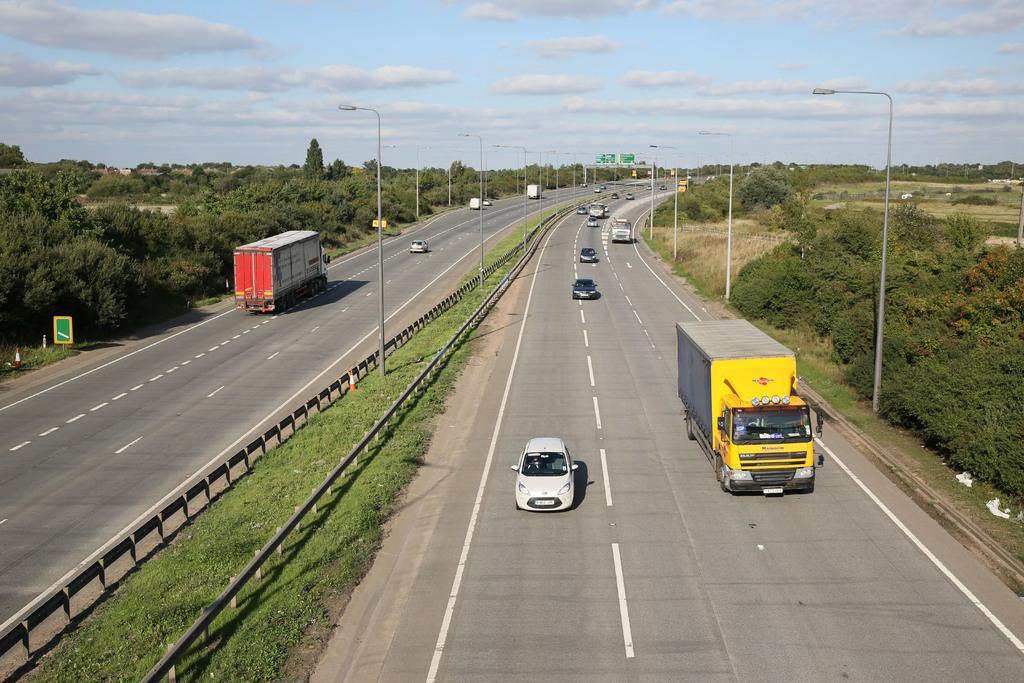Please provide a concise description of this image. This is completely an outdoor picture. In Between there is a road divider. This is green grass. This is a road. There a few vehicles running on the road and the other also vehicles running on the road. At the top of the picture we can see a blue sky and it seems like a sunny day. Afar there are way boards. These are the lights. 